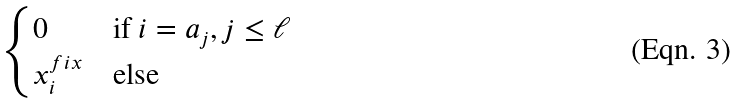<formula> <loc_0><loc_0><loc_500><loc_500>\begin{cases} 0 & \text {if } i = a _ { j } , j \leq \ell \\ x ^ { f i x } _ { i } & \text {else} \end{cases}</formula> 